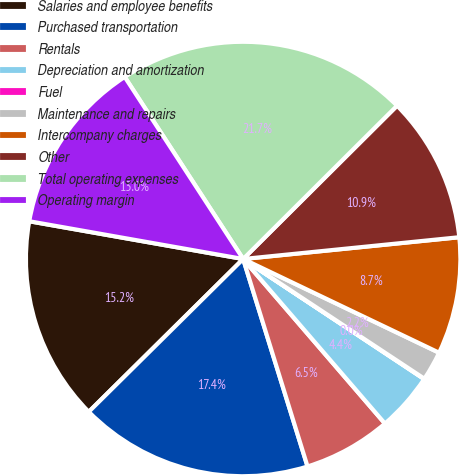Convert chart. <chart><loc_0><loc_0><loc_500><loc_500><pie_chart><fcel>Salaries and employee benefits<fcel>Purchased transportation<fcel>Rentals<fcel>Depreciation and amortization<fcel>Fuel<fcel>Maintenance and repairs<fcel>Intercompany charges<fcel>Other<fcel>Total operating expenses<fcel>Operating margin<nl><fcel>15.2%<fcel>17.37%<fcel>6.53%<fcel>4.36%<fcel>0.03%<fcel>2.19%<fcel>8.7%<fcel>10.87%<fcel>21.71%<fcel>13.04%<nl></chart> 